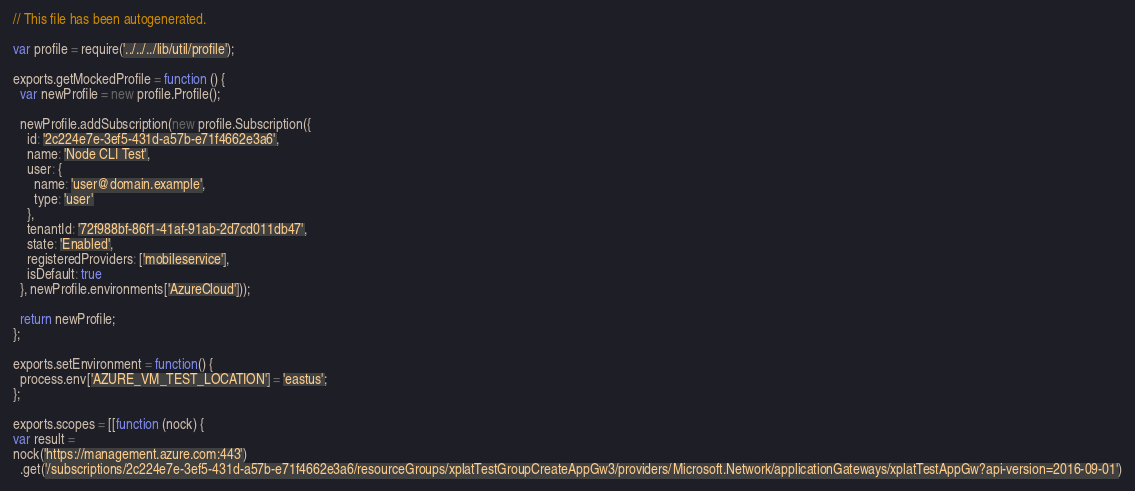Convert code to text. <code><loc_0><loc_0><loc_500><loc_500><_JavaScript_>// This file has been autogenerated.

var profile = require('../../../lib/util/profile');

exports.getMockedProfile = function () {
  var newProfile = new profile.Profile();

  newProfile.addSubscription(new profile.Subscription({
    id: '2c224e7e-3ef5-431d-a57b-e71f4662e3a6',
    name: 'Node CLI Test',
    user: {
      name: 'user@domain.example',
      type: 'user'
    },
    tenantId: '72f988bf-86f1-41af-91ab-2d7cd011db47',
    state: 'Enabled',
    registeredProviders: ['mobileservice'],
    isDefault: true
  }, newProfile.environments['AzureCloud']));

  return newProfile;
};

exports.setEnvironment = function() {
  process.env['AZURE_VM_TEST_LOCATION'] = 'eastus';
};

exports.scopes = [[function (nock) { 
var result = 
nock('https://management.azure.com:443')
  .get('/subscriptions/2c224e7e-3ef5-431d-a57b-e71f4662e3a6/resourceGroups/xplatTestGroupCreateAppGw3/providers/Microsoft.Network/applicationGateways/xplatTestAppGw?api-version=2016-09-01')</code> 